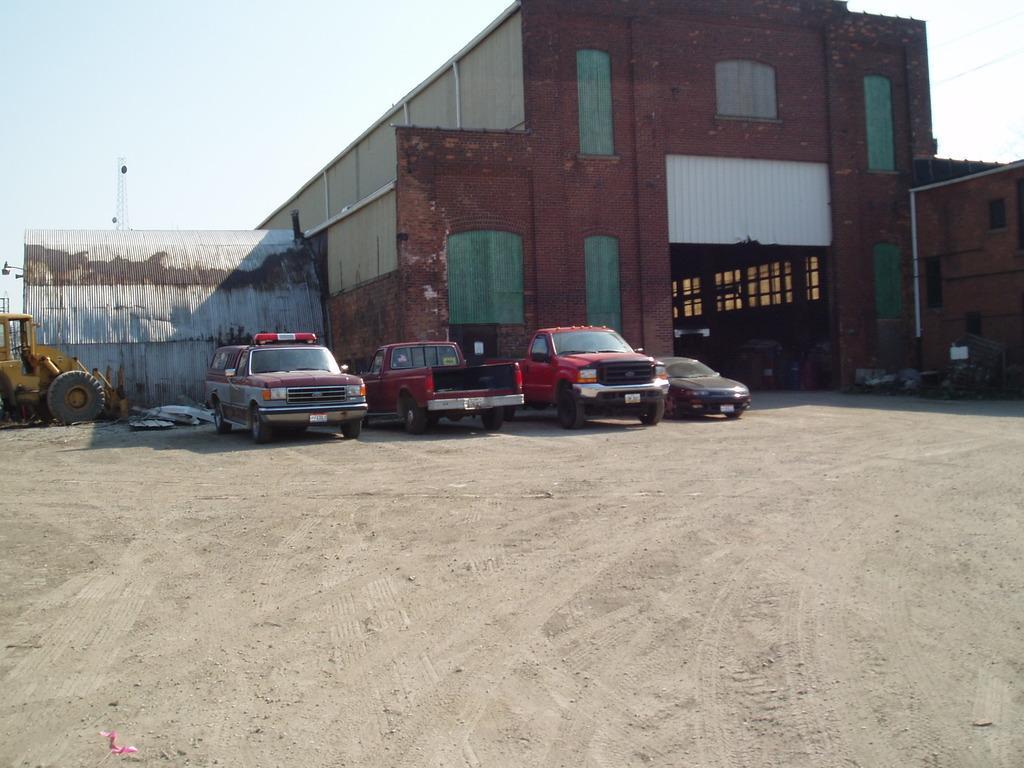Can you describe this image briefly? In this image I can see number of vehicles and in the background I can see a building, the sky and on the left side of this image I can see a tower. 